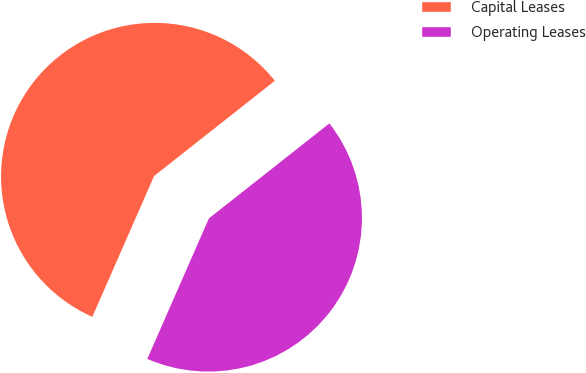<chart> <loc_0><loc_0><loc_500><loc_500><pie_chart><fcel>Capital Leases<fcel>Operating Leases<nl><fcel>57.79%<fcel>42.21%<nl></chart> 